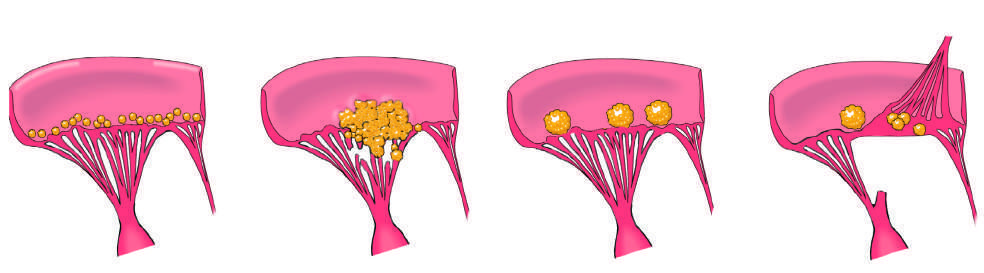how does non-bacterial thrombotic endocarditis manifest?
Answer the question using a single word or phrase. With small- to medium-sized 